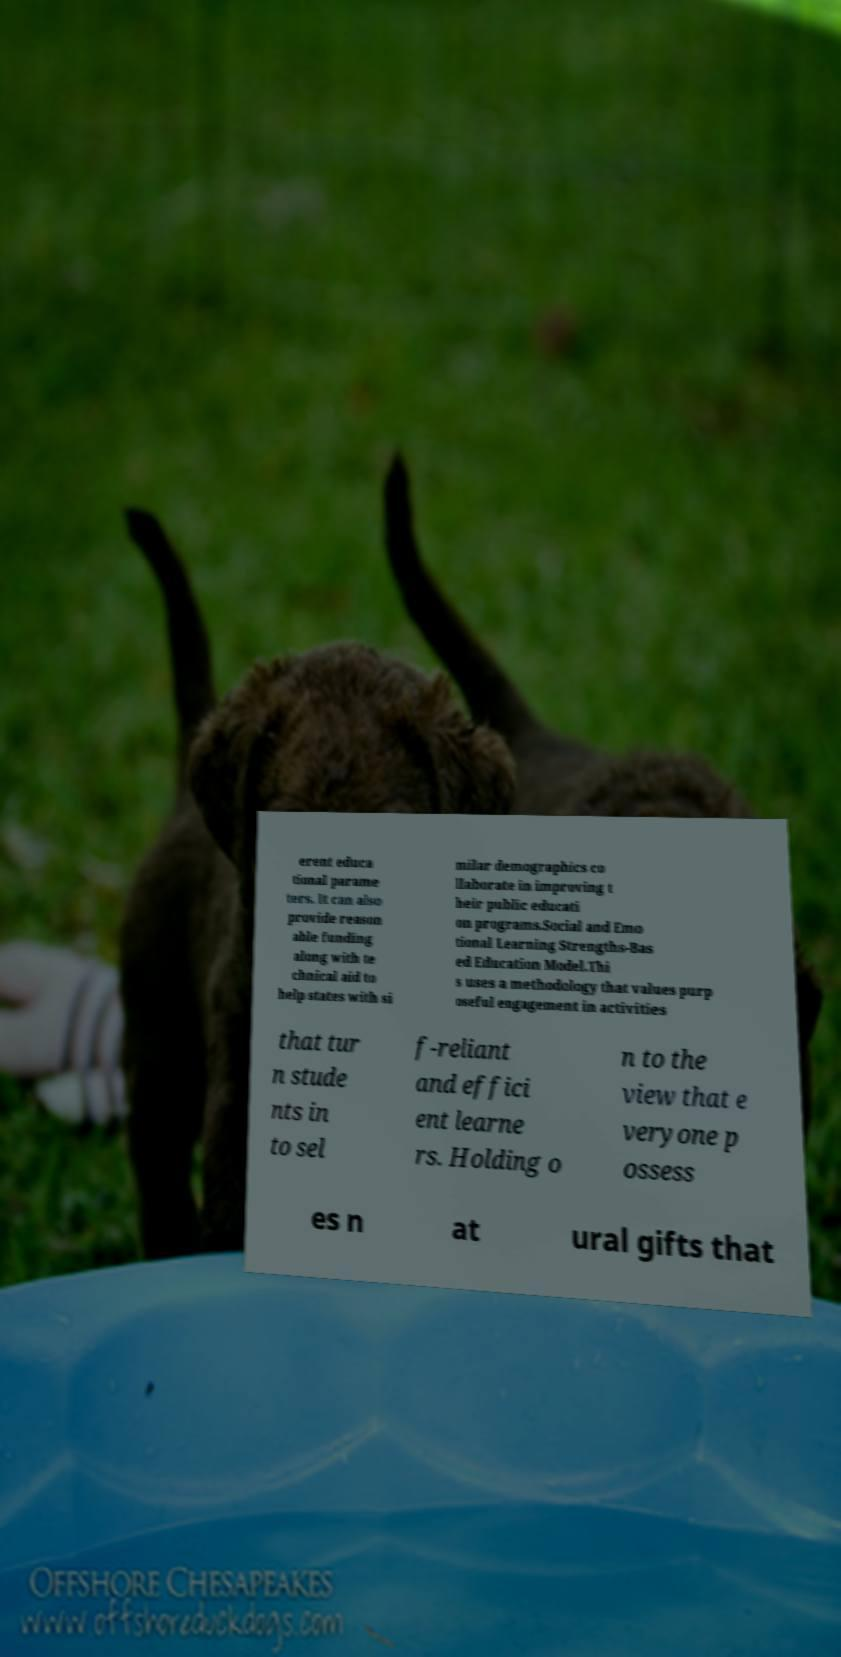There's text embedded in this image that I need extracted. Can you transcribe it verbatim? erent educa tional parame ters. It can also provide reason able funding along with te chnical aid to help states with si milar demographics co llaborate in improving t heir public educati on programs.Social and Emo tional Learning Strengths-Bas ed Education Model.Thi s uses a methodology that values purp oseful engagement in activities that tur n stude nts in to sel f-reliant and effici ent learne rs. Holding o n to the view that e veryone p ossess es n at ural gifts that 